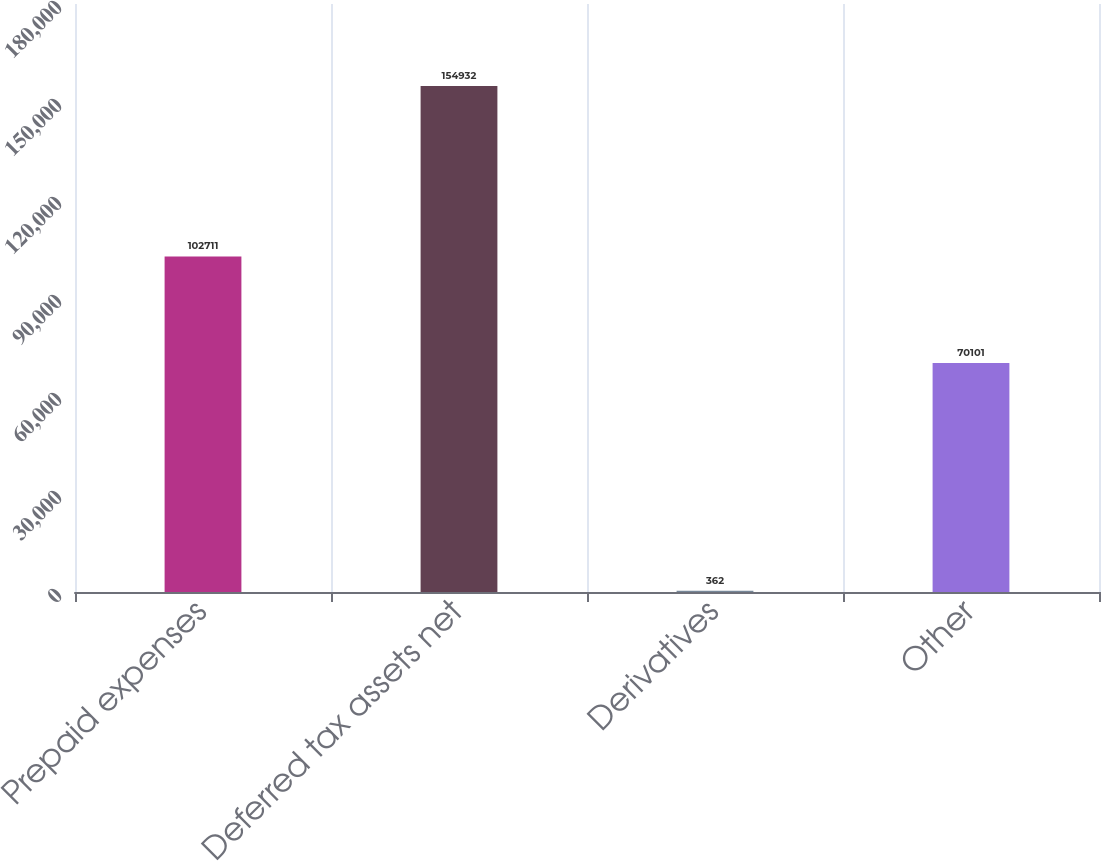Convert chart. <chart><loc_0><loc_0><loc_500><loc_500><bar_chart><fcel>Prepaid expenses<fcel>Deferred tax assets net<fcel>Derivatives<fcel>Other<nl><fcel>102711<fcel>154932<fcel>362<fcel>70101<nl></chart> 